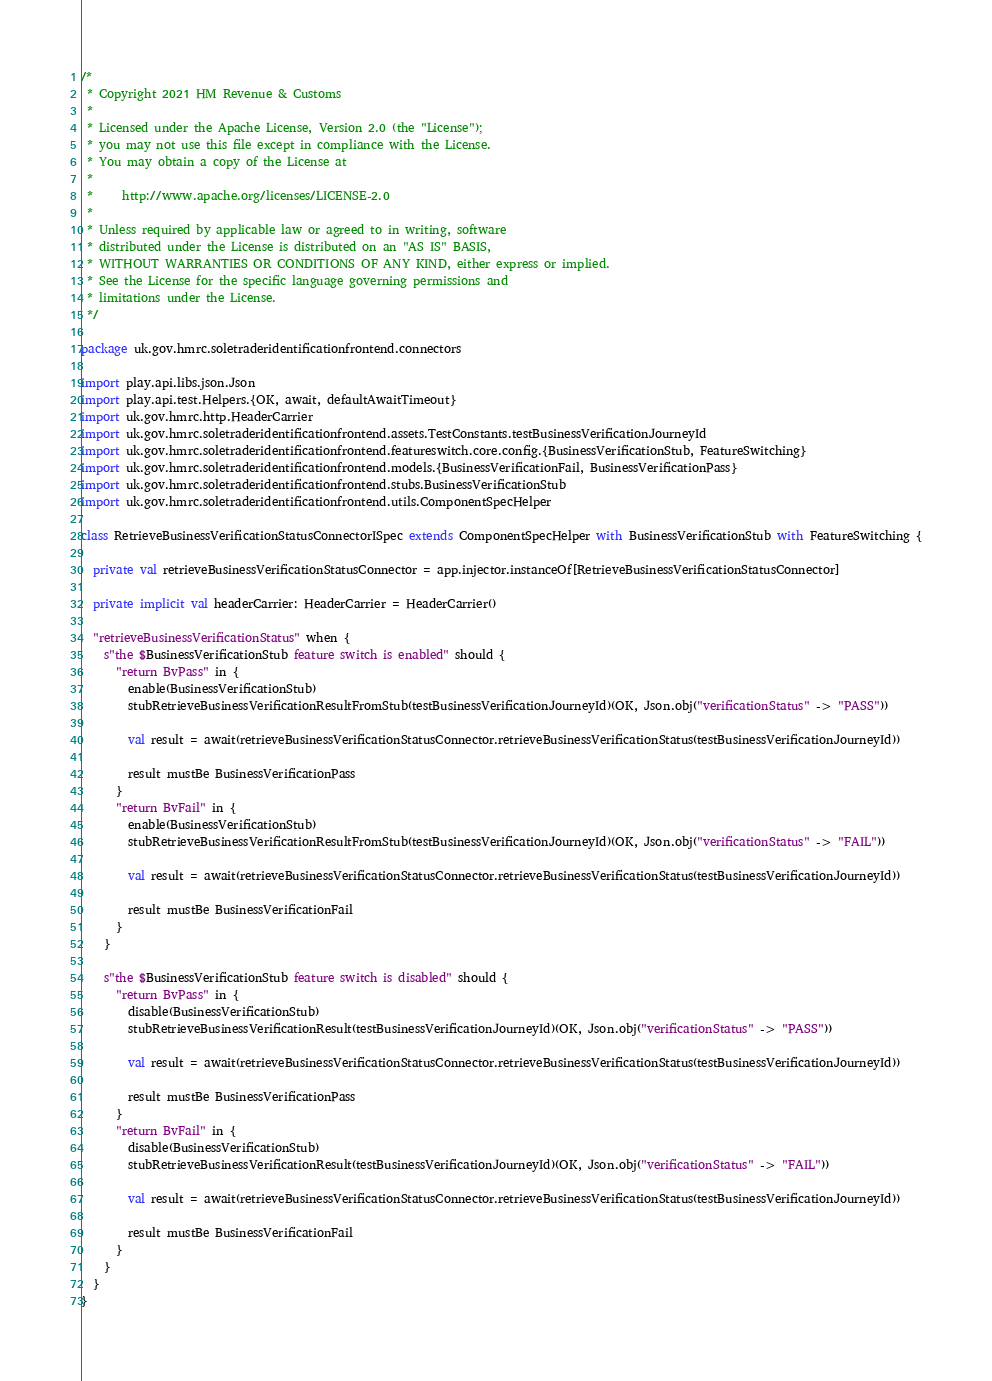Convert code to text. <code><loc_0><loc_0><loc_500><loc_500><_Scala_>/*
 * Copyright 2021 HM Revenue & Customs
 *
 * Licensed under the Apache License, Version 2.0 (the "License");
 * you may not use this file except in compliance with the License.
 * You may obtain a copy of the License at
 *
 *     http://www.apache.org/licenses/LICENSE-2.0
 *
 * Unless required by applicable law or agreed to in writing, software
 * distributed under the License is distributed on an "AS IS" BASIS,
 * WITHOUT WARRANTIES OR CONDITIONS OF ANY KIND, either express or implied.
 * See the License for the specific language governing permissions and
 * limitations under the License.
 */

package uk.gov.hmrc.soletraderidentificationfrontend.connectors

import play.api.libs.json.Json
import play.api.test.Helpers.{OK, await, defaultAwaitTimeout}
import uk.gov.hmrc.http.HeaderCarrier
import uk.gov.hmrc.soletraderidentificationfrontend.assets.TestConstants.testBusinessVerificationJourneyId
import uk.gov.hmrc.soletraderidentificationfrontend.featureswitch.core.config.{BusinessVerificationStub, FeatureSwitching}
import uk.gov.hmrc.soletraderidentificationfrontend.models.{BusinessVerificationFail, BusinessVerificationPass}
import uk.gov.hmrc.soletraderidentificationfrontend.stubs.BusinessVerificationStub
import uk.gov.hmrc.soletraderidentificationfrontend.utils.ComponentSpecHelper

class RetrieveBusinessVerificationStatusConnectorISpec extends ComponentSpecHelper with BusinessVerificationStub with FeatureSwitching {

  private val retrieveBusinessVerificationStatusConnector = app.injector.instanceOf[RetrieveBusinessVerificationStatusConnector]

  private implicit val headerCarrier: HeaderCarrier = HeaderCarrier()

  "retrieveBusinessVerificationStatus" when {
    s"the $BusinessVerificationStub feature switch is enabled" should {
      "return BvPass" in {
        enable(BusinessVerificationStub)
        stubRetrieveBusinessVerificationResultFromStub(testBusinessVerificationJourneyId)(OK, Json.obj("verificationStatus" -> "PASS"))

        val result = await(retrieveBusinessVerificationStatusConnector.retrieveBusinessVerificationStatus(testBusinessVerificationJourneyId))

        result mustBe BusinessVerificationPass
      }
      "return BvFail" in {
        enable(BusinessVerificationStub)
        stubRetrieveBusinessVerificationResultFromStub(testBusinessVerificationJourneyId)(OK, Json.obj("verificationStatus" -> "FAIL"))

        val result = await(retrieveBusinessVerificationStatusConnector.retrieveBusinessVerificationStatus(testBusinessVerificationJourneyId))

        result mustBe BusinessVerificationFail
      }
    }

    s"the $BusinessVerificationStub feature switch is disabled" should {
      "return BvPass" in {
        disable(BusinessVerificationStub)
        stubRetrieveBusinessVerificationResult(testBusinessVerificationJourneyId)(OK, Json.obj("verificationStatus" -> "PASS"))

        val result = await(retrieveBusinessVerificationStatusConnector.retrieveBusinessVerificationStatus(testBusinessVerificationJourneyId))

        result mustBe BusinessVerificationPass
      }
      "return BvFail" in {
        disable(BusinessVerificationStub)
        stubRetrieveBusinessVerificationResult(testBusinessVerificationJourneyId)(OK, Json.obj("verificationStatus" -> "FAIL"))

        val result = await(retrieveBusinessVerificationStatusConnector.retrieveBusinessVerificationStatus(testBusinessVerificationJourneyId))

        result mustBe BusinessVerificationFail
      }
    }
  }
}

</code> 